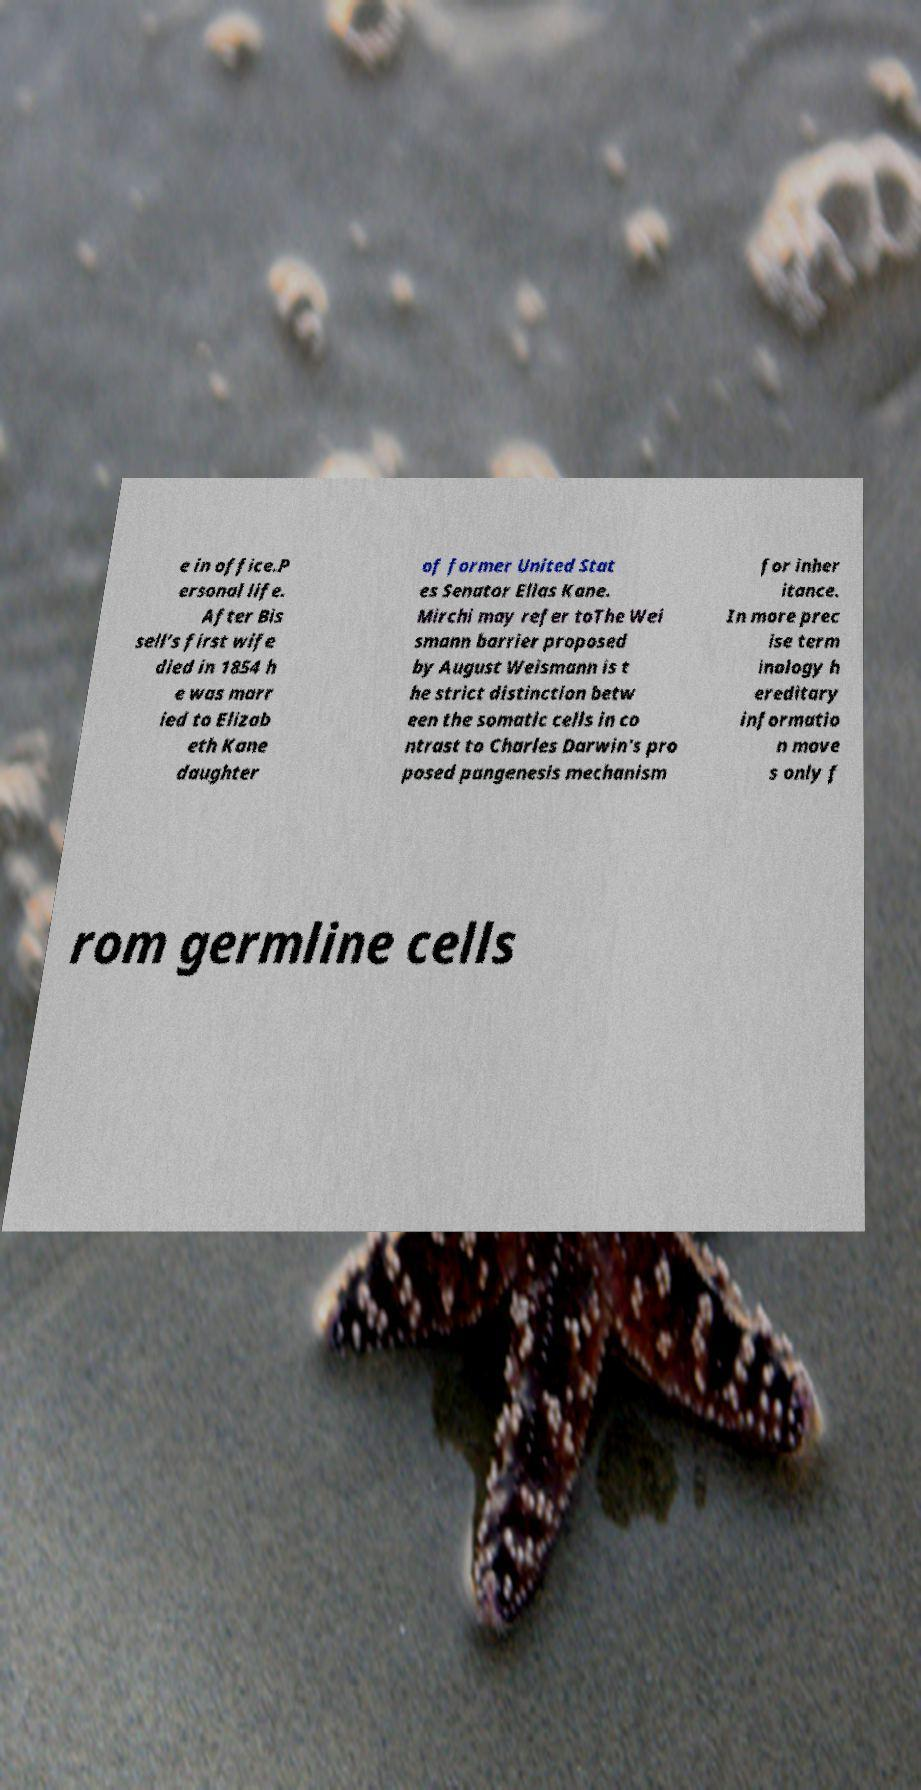Could you extract and type out the text from this image? e in office.P ersonal life. After Bis sell’s first wife died in 1854 h e was marr ied to Elizab eth Kane daughter of former United Stat es Senator Elias Kane. Mirchi may refer toThe Wei smann barrier proposed by August Weismann is t he strict distinction betw een the somatic cells in co ntrast to Charles Darwin's pro posed pangenesis mechanism for inher itance. In more prec ise term inology h ereditary informatio n move s only f rom germline cells 